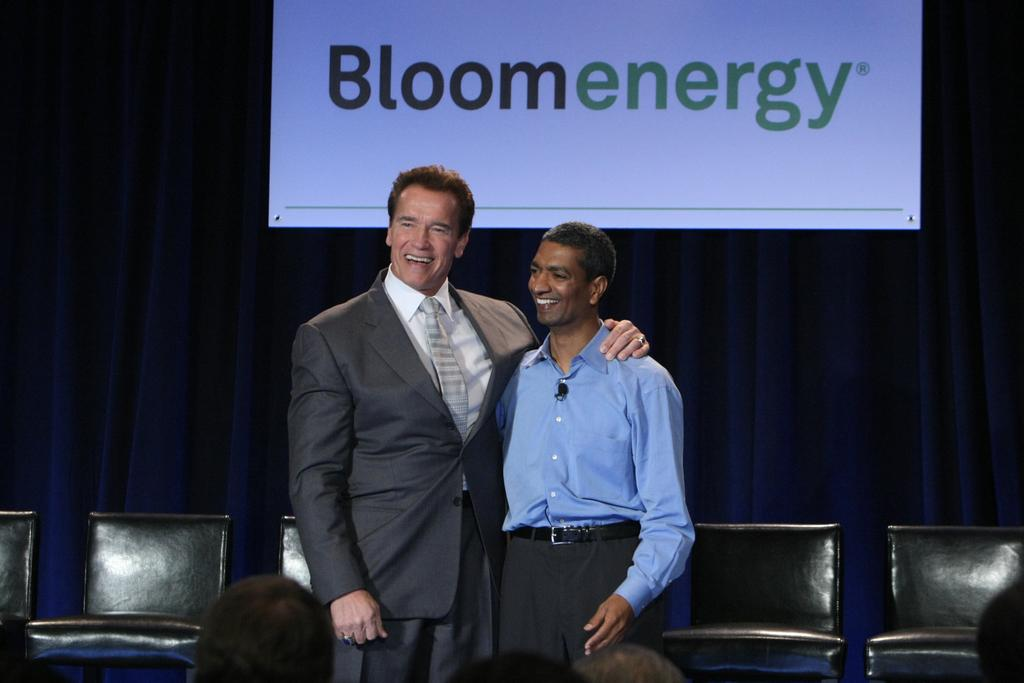How many people are present in the image? There are two persons standing in the image. What is the surface on which the persons are standing? The persons are standing on the floor. What type of furniture can be seen in the image? There are chairs in the image. What is visible in the background of the image? There is a screen in the background of the image. What type of window treatment is present in the image? There is a curtain in the image. What type of cattle can be seen grazing in the image? There is no cattle present in the image; it features two persons standing on the floor with chairs and a screen in the background. What is the desire of the persons in the image? The image does not provide any information about the desires or intentions of the persons. 